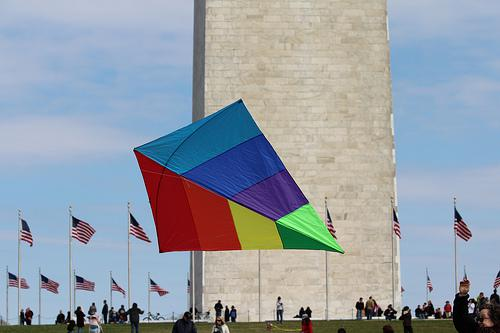Question: who is around the flags?
Choices:
A. Kids.
B. Principles.
C. People.
D. Animals.
Answer with the letter. Answer: C Question: what color is the kite?
Choices:
A. Fuschia.
B. Purple.
C. Rainbow.
D. Blue and white.
Answer with the letter. Answer: C Question: what color is the monument?
Choices:
A. White.
B. Black.
C. Silver.
D. Gray.
Answer with the letter. Answer: D Question: where is the kite?
Choices:
A. Sky.
B. Ground.
C. In child's hand.
D. Up front.
Answer with the letter. Answer: D Question: how many flags are there?
Choices:
A. One.
B. Two.
C. Four.
D. More than five.
Answer with the letter. Answer: D 